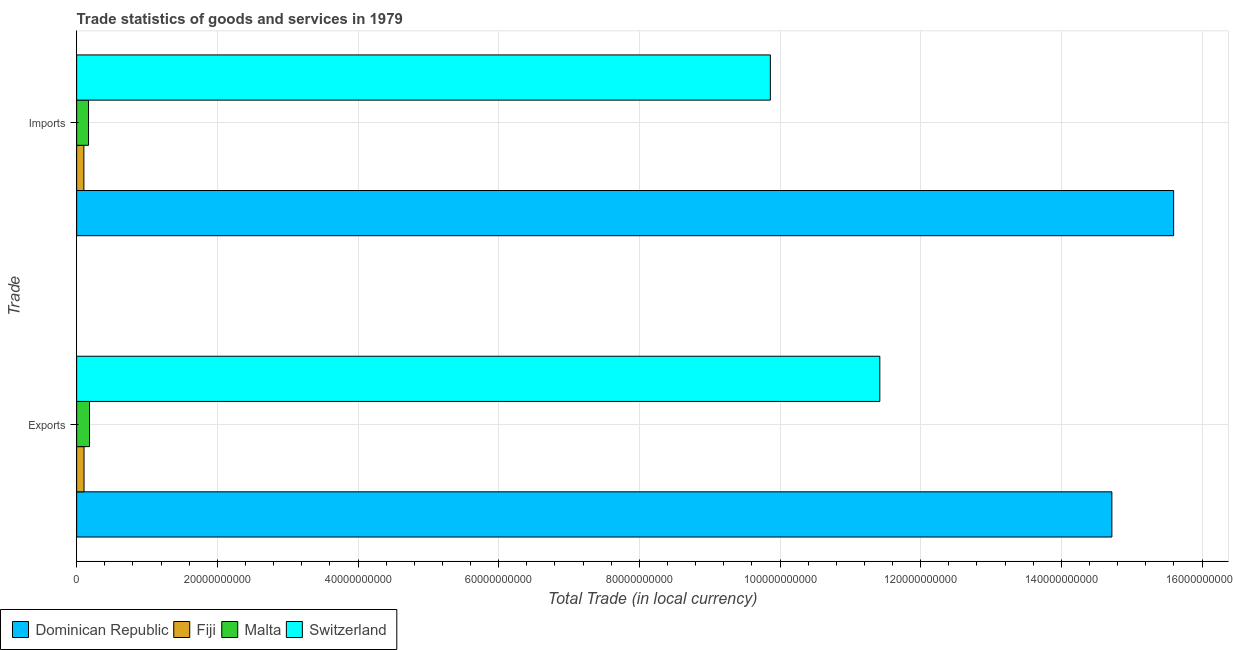How many groups of bars are there?
Ensure brevity in your answer.  2. Are the number of bars on each tick of the Y-axis equal?
Your answer should be very brief. Yes. What is the label of the 2nd group of bars from the top?
Your answer should be compact. Exports. What is the export of goods and services in Fiji?
Your answer should be very brief. 1.05e+09. Across all countries, what is the maximum export of goods and services?
Provide a short and direct response. 1.47e+11. Across all countries, what is the minimum export of goods and services?
Offer a very short reply. 1.05e+09. In which country was the export of goods and services maximum?
Make the answer very short. Dominican Republic. In which country was the imports of goods and services minimum?
Your answer should be compact. Fiji. What is the total export of goods and services in the graph?
Offer a terse response. 2.64e+11. What is the difference between the export of goods and services in Switzerland and that in Fiji?
Give a very brief answer. 1.13e+11. What is the difference between the export of goods and services in Malta and the imports of goods and services in Switzerland?
Provide a succinct answer. -9.68e+1. What is the average imports of goods and services per country?
Make the answer very short. 6.43e+1. What is the difference between the export of goods and services and imports of goods and services in Fiji?
Ensure brevity in your answer.  1.89e+07. What is the ratio of the imports of goods and services in Dominican Republic to that in Fiji?
Your answer should be very brief. 151.64. In how many countries, is the export of goods and services greater than the average export of goods and services taken over all countries?
Ensure brevity in your answer.  2. What does the 3rd bar from the top in Exports represents?
Offer a terse response. Fiji. What does the 1st bar from the bottom in Imports represents?
Provide a short and direct response. Dominican Republic. How many bars are there?
Provide a short and direct response. 8. Are all the bars in the graph horizontal?
Make the answer very short. Yes. Are the values on the major ticks of X-axis written in scientific E-notation?
Your response must be concise. No. How many legend labels are there?
Your answer should be very brief. 4. What is the title of the graph?
Keep it short and to the point. Trade statistics of goods and services in 1979. Does "Indonesia" appear as one of the legend labels in the graph?
Provide a short and direct response. No. What is the label or title of the X-axis?
Your response must be concise. Total Trade (in local currency). What is the label or title of the Y-axis?
Offer a terse response. Trade. What is the Total Trade (in local currency) in Dominican Republic in Exports?
Offer a terse response. 1.47e+11. What is the Total Trade (in local currency) of Fiji in Exports?
Offer a very short reply. 1.05e+09. What is the Total Trade (in local currency) of Malta in Exports?
Provide a short and direct response. 1.83e+09. What is the Total Trade (in local currency) of Switzerland in Exports?
Give a very brief answer. 1.14e+11. What is the Total Trade (in local currency) of Dominican Republic in Imports?
Offer a very short reply. 1.56e+11. What is the Total Trade (in local currency) in Fiji in Imports?
Provide a short and direct response. 1.03e+09. What is the Total Trade (in local currency) in Malta in Imports?
Make the answer very short. 1.69e+09. What is the Total Trade (in local currency) in Switzerland in Imports?
Your answer should be very brief. 9.86e+1. Across all Trade, what is the maximum Total Trade (in local currency) of Dominican Republic?
Provide a succinct answer. 1.56e+11. Across all Trade, what is the maximum Total Trade (in local currency) in Fiji?
Keep it short and to the point. 1.05e+09. Across all Trade, what is the maximum Total Trade (in local currency) in Malta?
Provide a short and direct response. 1.83e+09. Across all Trade, what is the maximum Total Trade (in local currency) in Switzerland?
Ensure brevity in your answer.  1.14e+11. Across all Trade, what is the minimum Total Trade (in local currency) of Dominican Republic?
Make the answer very short. 1.47e+11. Across all Trade, what is the minimum Total Trade (in local currency) of Fiji?
Your answer should be compact. 1.03e+09. Across all Trade, what is the minimum Total Trade (in local currency) in Malta?
Your answer should be compact. 1.69e+09. Across all Trade, what is the minimum Total Trade (in local currency) of Switzerland?
Provide a short and direct response. 9.86e+1. What is the total Total Trade (in local currency) in Dominican Republic in the graph?
Offer a terse response. 3.03e+11. What is the total Total Trade (in local currency) in Fiji in the graph?
Offer a terse response. 2.08e+09. What is the total Total Trade (in local currency) in Malta in the graph?
Your answer should be very brief. 3.52e+09. What is the total Total Trade (in local currency) in Switzerland in the graph?
Your answer should be very brief. 2.13e+11. What is the difference between the Total Trade (in local currency) in Dominican Republic in Exports and that in Imports?
Offer a terse response. -8.78e+09. What is the difference between the Total Trade (in local currency) of Fiji in Exports and that in Imports?
Provide a short and direct response. 1.89e+07. What is the difference between the Total Trade (in local currency) in Malta in Exports and that in Imports?
Offer a very short reply. 1.43e+08. What is the difference between the Total Trade (in local currency) in Switzerland in Exports and that in Imports?
Offer a terse response. 1.56e+1. What is the difference between the Total Trade (in local currency) in Dominican Republic in Exports and the Total Trade (in local currency) in Fiji in Imports?
Your answer should be very brief. 1.46e+11. What is the difference between the Total Trade (in local currency) of Dominican Republic in Exports and the Total Trade (in local currency) of Malta in Imports?
Give a very brief answer. 1.45e+11. What is the difference between the Total Trade (in local currency) in Dominican Republic in Exports and the Total Trade (in local currency) in Switzerland in Imports?
Make the answer very short. 4.86e+1. What is the difference between the Total Trade (in local currency) of Fiji in Exports and the Total Trade (in local currency) of Malta in Imports?
Offer a very short reply. -6.39e+08. What is the difference between the Total Trade (in local currency) of Fiji in Exports and the Total Trade (in local currency) of Switzerland in Imports?
Keep it short and to the point. -9.76e+1. What is the difference between the Total Trade (in local currency) in Malta in Exports and the Total Trade (in local currency) in Switzerland in Imports?
Provide a succinct answer. -9.68e+1. What is the average Total Trade (in local currency) in Dominican Republic per Trade?
Ensure brevity in your answer.  1.52e+11. What is the average Total Trade (in local currency) of Fiji per Trade?
Give a very brief answer. 1.04e+09. What is the average Total Trade (in local currency) of Malta per Trade?
Make the answer very short. 1.76e+09. What is the average Total Trade (in local currency) of Switzerland per Trade?
Your answer should be compact. 1.06e+11. What is the difference between the Total Trade (in local currency) in Dominican Republic and Total Trade (in local currency) in Fiji in Exports?
Your response must be concise. 1.46e+11. What is the difference between the Total Trade (in local currency) of Dominican Republic and Total Trade (in local currency) of Malta in Exports?
Your answer should be compact. 1.45e+11. What is the difference between the Total Trade (in local currency) of Dominican Republic and Total Trade (in local currency) of Switzerland in Exports?
Keep it short and to the point. 3.30e+1. What is the difference between the Total Trade (in local currency) in Fiji and Total Trade (in local currency) in Malta in Exports?
Your response must be concise. -7.83e+08. What is the difference between the Total Trade (in local currency) in Fiji and Total Trade (in local currency) in Switzerland in Exports?
Keep it short and to the point. -1.13e+11. What is the difference between the Total Trade (in local currency) of Malta and Total Trade (in local currency) of Switzerland in Exports?
Give a very brief answer. -1.12e+11. What is the difference between the Total Trade (in local currency) of Dominican Republic and Total Trade (in local currency) of Fiji in Imports?
Your answer should be very brief. 1.55e+11. What is the difference between the Total Trade (in local currency) in Dominican Republic and Total Trade (in local currency) in Malta in Imports?
Your response must be concise. 1.54e+11. What is the difference between the Total Trade (in local currency) in Dominican Republic and Total Trade (in local currency) in Switzerland in Imports?
Your answer should be very brief. 5.73e+1. What is the difference between the Total Trade (in local currency) in Fiji and Total Trade (in local currency) in Malta in Imports?
Offer a terse response. -6.58e+08. What is the difference between the Total Trade (in local currency) in Fiji and Total Trade (in local currency) in Switzerland in Imports?
Give a very brief answer. -9.76e+1. What is the difference between the Total Trade (in local currency) of Malta and Total Trade (in local currency) of Switzerland in Imports?
Your response must be concise. -9.69e+1. What is the ratio of the Total Trade (in local currency) in Dominican Republic in Exports to that in Imports?
Make the answer very short. 0.94. What is the ratio of the Total Trade (in local currency) of Fiji in Exports to that in Imports?
Give a very brief answer. 1.02. What is the ratio of the Total Trade (in local currency) of Malta in Exports to that in Imports?
Your response must be concise. 1.09. What is the ratio of the Total Trade (in local currency) in Switzerland in Exports to that in Imports?
Ensure brevity in your answer.  1.16. What is the difference between the highest and the second highest Total Trade (in local currency) of Dominican Republic?
Your answer should be very brief. 8.78e+09. What is the difference between the highest and the second highest Total Trade (in local currency) of Fiji?
Offer a very short reply. 1.89e+07. What is the difference between the highest and the second highest Total Trade (in local currency) in Malta?
Offer a terse response. 1.43e+08. What is the difference between the highest and the second highest Total Trade (in local currency) in Switzerland?
Provide a short and direct response. 1.56e+1. What is the difference between the highest and the lowest Total Trade (in local currency) in Dominican Republic?
Provide a short and direct response. 8.78e+09. What is the difference between the highest and the lowest Total Trade (in local currency) in Fiji?
Make the answer very short. 1.89e+07. What is the difference between the highest and the lowest Total Trade (in local currency) in Malta?
Provide a short and direct response. 1.43e+08. What is the difference between the highest and the lowest Total Trade (in local currency) in Switzerland?
Your answer should be very brief. 1.56e+1. 